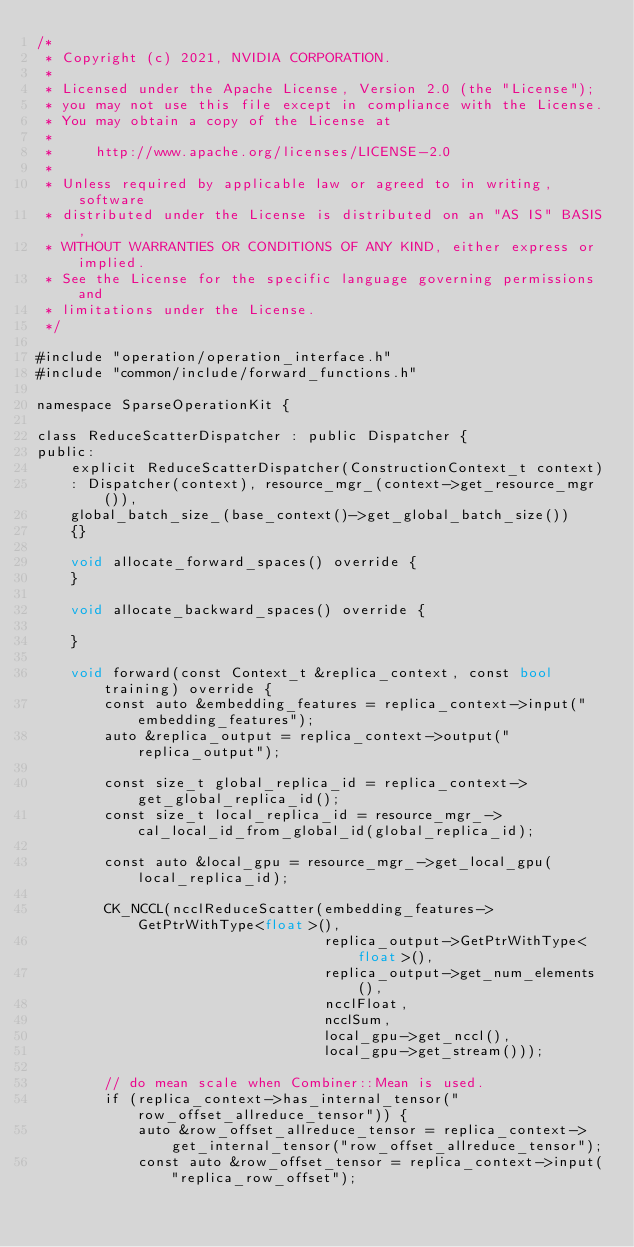<code> <loc_0><loc_0><loc_500><loc_500><_Cuda_>/*
 * Copyright (c) 2021, NVIDIA CORPORATION.
 *
 * Licensed under the Apache License, Version 2.0 (the "License");
 * you may not use this file except in compliance with the License.
 * You may obtain a copy of the License at
 *
 *     http://www.apache.org/licenses/LICENSE-2.0
 *
 * Unless required by applicable law or agreed to in writing, software
 * distributed under the License is distributed on an "AS IS" BASIS,
 * WITHOUT WARRANTIES OR CONDITIONS OF ANY KIND, either express or implied.
 * See the License for the specific language governing permissions and
 * limitations under the License.
 */

#include "operation/operation_interface.h"
#include "common/include/forward_functions.h"

namespace SparseOperationKit {

class ReduceScatterDispatcher : public Dispatcher {
public:
    explicit ReduceScatterDispatcher(ConstructionContext_t context)
    : Dispatcher(context), resource_mgr_(context->get_resource_mgr()),
    global_batch_size_(base_context()->get_global_batch_size())
    {}

    void allocate_forward_spaces() override {
    }

    void allocate_backward_spaces() override {

    }

    void forward(const Context_t &replica_context, const bool training) override {
        const auto &embedding_features = replica_context->input("embedding_features");
        auto &replica_output = replica_context->output("replica_output");

        const size_t global_replica_id = replica_context->get_global_replica_id();
        const size_t local_replica_id = resource_mgr_->cal_local_id_from_global_id(global_replica_id);

        const auto &local_gpu = resource_mgr_->get_local_gpu(local_replica_id);

        CK_NCCL(ncclReduceScatter(embedding_features->GetPtrWithType<float>(),
                                  replica_output->GetPtrWithType<float>(),
                                  replica_output->get_num_elements(),
                                  ncclFloat,
                                  ncclSum,
                                  local_gpu->get_nccl(),
                                  local_gpu->get_stream()));

        // do mean scale when Combiner::Mean is used.
        if (replica_context->has_internal_tensor("row_offset_allreduce_tensor")) {
            auto &row_offset_allreduce_tensor = replica_context->get_internal_tensor("row_offset_allreduce_tensor");
            const auto &row_offset_tensor = replica_context->input("replica_row_offset");
</code> 